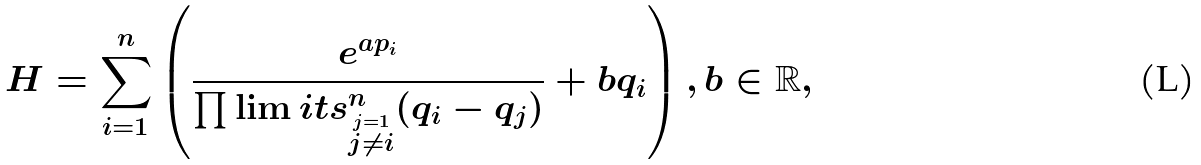Convert formula to latex. <formula><loc_0><loc_0><loc_500><loc_500>H = \sum _ { i = 1 } ^ { n } \left ( \frac { e ^ { a p _ { i } } } { \prod \lim i t s _ { \stackrel { j = 1 } { j \neq i } } ^ { n } ( q _ { i } - q _ { j } ) } + b q _ { i } \right ) , b \in \mathbb { R } ,</formula> 